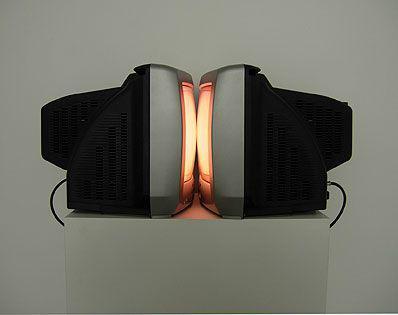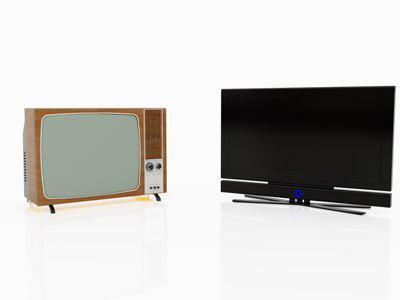The first image is the image on the left, the second image is the image on the right. For the images shown, is this caption "An image shows a smaller dark-screened TV with a bigger dark-screened TV, and both are sitting on some type of surface." true? Answer yes or no. No. The first image is the image on the left, the second image is the image on the right. For the images displayed, is the sentence "Two televisions touch each other in at least one of the images." factually correct? Answer yes or no. Yes. 